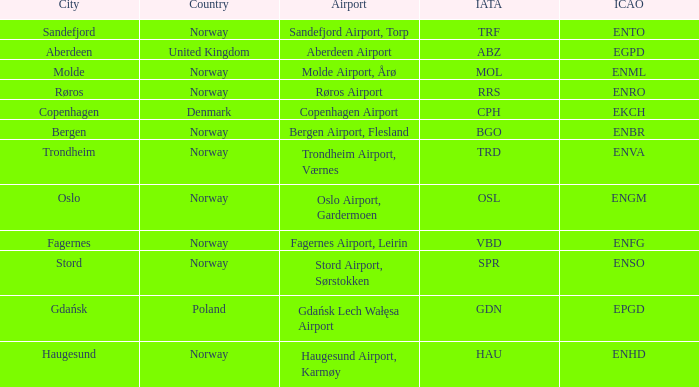Could you parse the entire table as a dict? {'header': ['City', 'Country', 'Airport', 'IATA', 'ICAO'], 'rows': [['Sandefjord', 'Norway', 'Sandefjord Airport, Torp', 'TRF', 'ENTO'], ['Aberdeen', 'United Kingdom', 'Aberdeen Airport', 'ABZ', 'EGPD'], ['Molde', 'Norway', 'Molde Airport, Årø', 'MOL', 'ENML'], ['Røros', 'Norway', 'Røros Airport', 'RRS', 'ENRO'], ['Copenhagen', 'Denmark', 'Copenhagen Airport', 'CPH', 'EKCH'], ['Bergen', 'Norway', 'Bergen Airport, Flesland', 'BGO', 'ENBR'], ['Trondheim', 'Norway', 'Trondheim Airport, Værnes', 'TRD', 'ENVA'], ['Oslo', 'Norway', 'Oslo Airport, Gardermoen', 'OSL', 'ENGM'], ['Fagernes', 'Norway', 'Fagernes Airport, Leirin', 'VBD', 'ENFG'], ['Stord', 'Norway', 'Stord Airport, Sørstokken', 'SPR', 'ENSO'], ['Gdańsk', 'Poland', 'Gdańsk Lech Wałęsa Airport', 'GDN', 'EPGD'], ['Haugesund', 'Norway', 'Haugesund Airport, Karmøy', 'HAU', 'ENHD']]} What Country has a ICAO of EKCH? Denmark. 